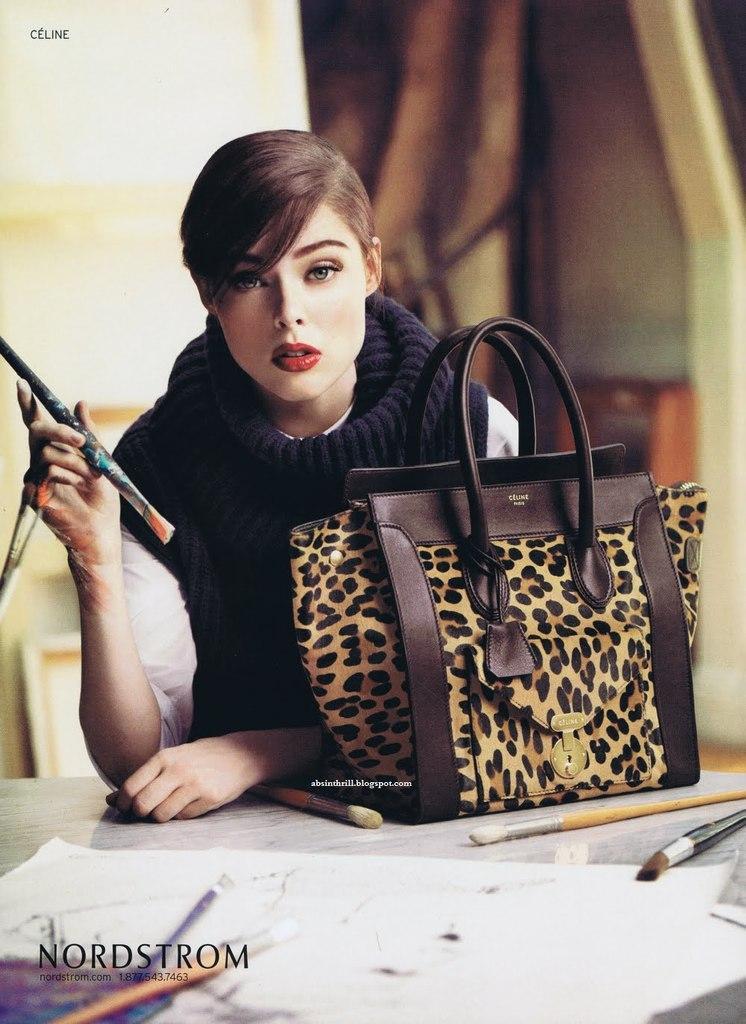Could you give a brief overview of what you see in this image? In this picture we can see women wore scarf holding brush in one hand and in front of her we can see table and on table we can see papers, bag, brushes and in background it is blurry. 